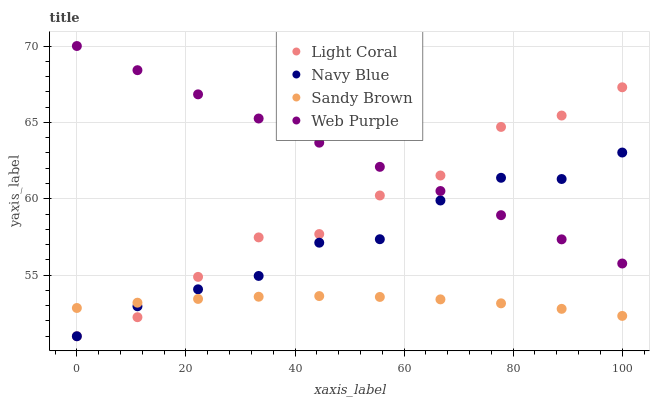Does Sandy Brown have the minimum area under the curve?
Answer yes or no. Yes. Does Web Purple have the maximum area under the curve?
Answer yes or no. Yes. Does Navy Blue have the minimum area under the curve?
Answer yes or no. No. Does Navy Blue have the maximum area under the curve?
Answer yes or no. No. Is Web Purple the smoothest?
Answer yes or no. Yes. Is Light Coral the roughest?
Answer yes or no. Yes. Is Navy Blue the smoothest?
Answer yes or no. No. Is Navy Blue the roughest?
Answer yes or no. No. Does Light Coral have the lowest value?
Answer yes or no. Yes. Does Web Purple have the lowest value?
Answer yes or no. No. Does Web Purple have the highest value?
Answer yes or no. Yes. Does Navy Blue have the highest value?
Answer yes or no. No. Is Sandy Brown less than Web Purple?
Answer yes or no. Yes. Is Web Purple greater than Sandy Brown?
Answer yes or no. Yes. Does Light Coral intersect Web Purple?
Answer yes or no. Yes. Is Light Coral less than Web Purple?
Answer yes or no. No. Is Light Coral greater than Web Purple?
Answer yes or no. No. Does Sandy Brown intersect Web Purple?
Answer yes or no. No. 